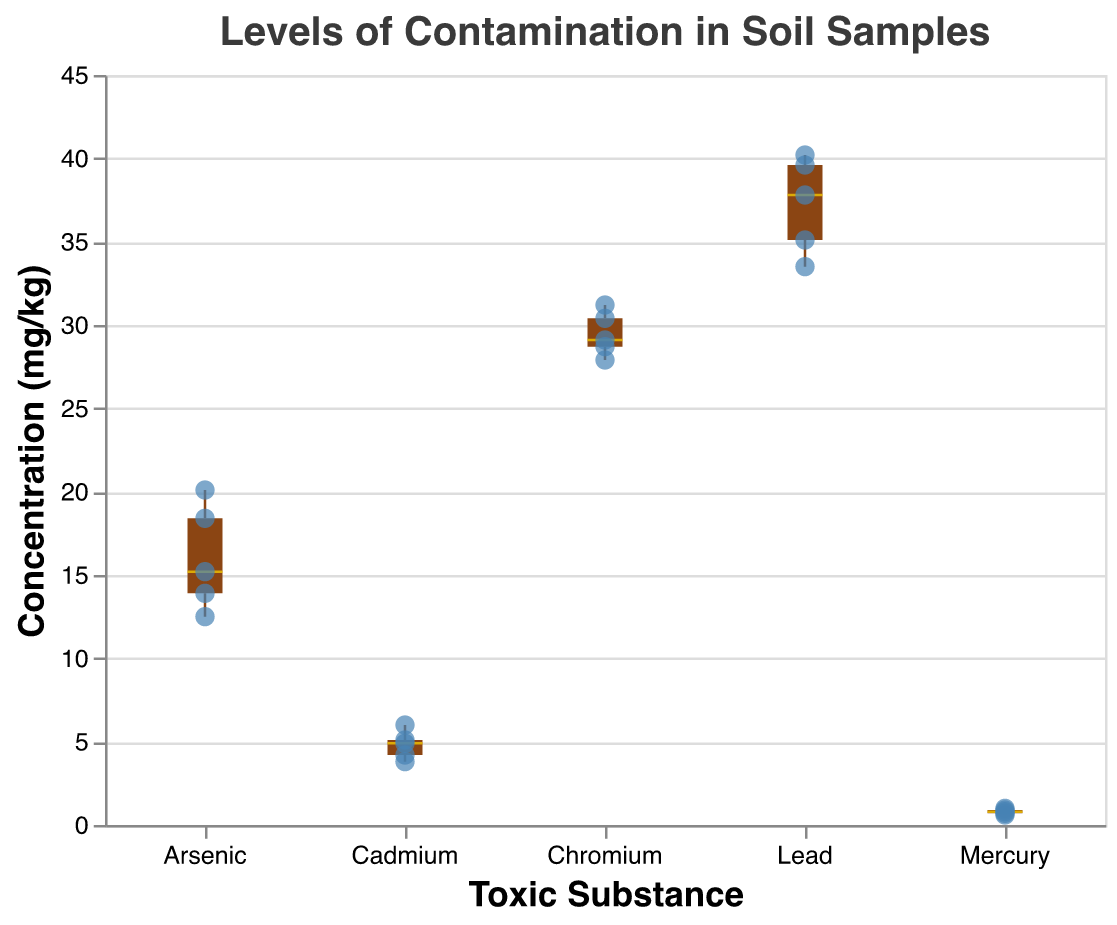What is the title of the figure? The title of the figure is located at the top and reads, "Levels of Contamination in Soil Samples".
Answer: Levels of Contamination in Soil Samples What toxic substance has the highest median concentration? Median values are represented by the golden line in each boxplot. The toxic substance with the highest median line is Lead.
Answer: Lead How many data points are there for each substance? Each scatter point represents a data point. By counting the scatter points, there are 5 data points for each substance: Arsenic, Lead, Cadmium, Mercury, and Chromium.
Answer: 5 What is the substance with the lowest minimum concentration, and what is that concentration? The minimum concentration is at the bottom of each boxplot's whisker. Mercury has the lowest minimum concentration, which is 0.6 mg/kg.
Answer: Mercury, 0.6 mg/kg Compare the range of concentrations for Arsenic and Cadmium. Which one is wider? The range can be determined by subtracting the minimum value from the maximum value for each substance. Arsenic’s range is (20.1 - 12.5) = 7.6 mg/kg, and Cadmium's range is (6.0 - 3.8) = 2.2 mg/kg. Arsenic has a wider range.
Answer: Arsenic Which substance appears to have the most consistent concentrations? Consistency can be visually assessed by looking at the box's interquartile range (IQR) and the whiskers. Mercury has the smallest IQR and shortest whiskers, indicating the most consistent concentrations.
Answer: Mercury How does the concentration of Lead compare to Chromium on average? The average can be estimated by looking at the central tendency (median and mean) within the boxplot. Lead’s central tendency is around 37-38 mg/kg, while Chromium’s is around 28-30 mg/kg, making Lead generally higher than Chromium.
Answer: Lead is generally higher than Chromium In terms of IQR (Interquartile Range), which substance has the most variability? The IQR is the height of the box in the boxplot. Lead appears to have the tallest box, indicating the largest IQR and most variability.
Answer: Lead Which substance has data points that are furthest from its median? The points furthest from the median are outliers. For Arsenic, the concentration of 12.5 mg/kg is quite far from the median.
Answer: Arsenic What is the maximum concentration recorded for Chromium, and how does it compare to Lead's maximum? The maximum concentration is at the top of the whisker. Chromium's max is 31.2 mg/kg, while Lead's max is 40.2 mg/kg. Lead’s maximum is higher.
Answer: Chromium: 31.2 mg/kg, Lead: 40.2 mg/kg 